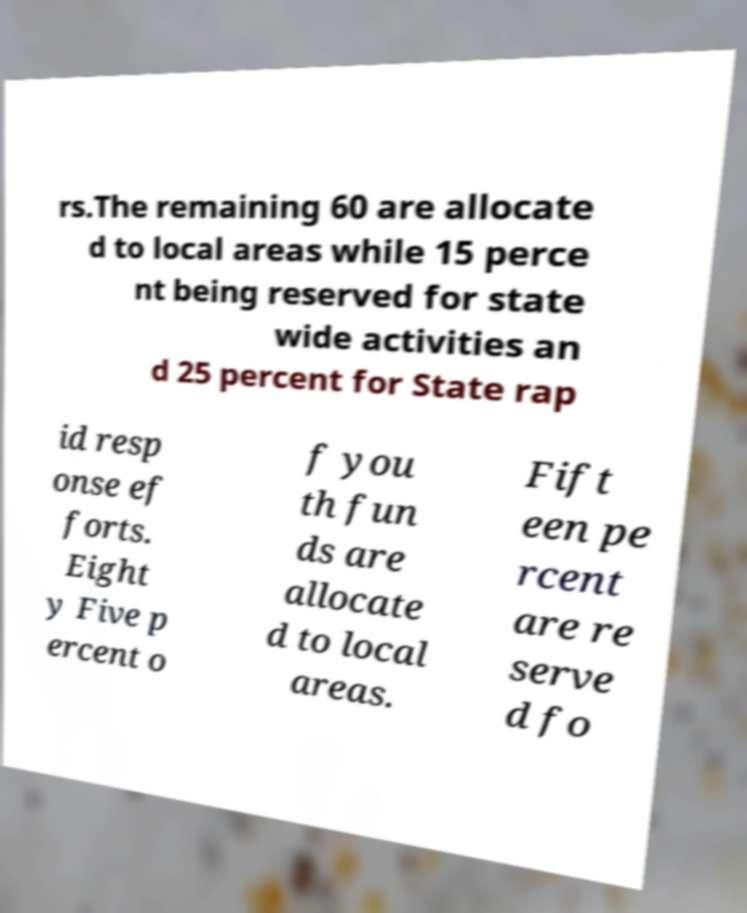There's text embedded in this image that I need extracted. Can you transcribe it verbatim? rs.The remaining 60 are allocate d to local areas while 15 perce nt being reserved for state wide activities an d 25 percent for State rap id resp onse ef forts. Eight y Five p ercent o f you th fun ds are allocate d to local areas. Fift een pe rcent are re serve d fo 